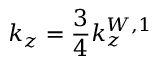<formula> <loc_0><loc_0><loc_500><loc_500>k _ { z } = \frac { 3 } { 4 } k _ { z } ^ { W , 1 }</formula> 